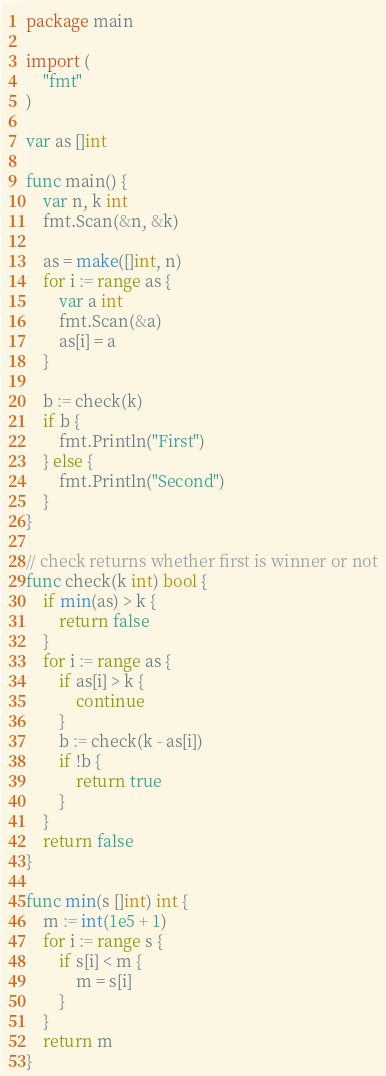<code> <loc_0><loc_0><loc_500><loc_500><_Go_>package main

import (
    "fmt"
)

var as []int

func main() {
    var n, k int
    fmt.Scan(&n, &k)

    as = make([]int, n)
    for i := range as {
        var a int
        fmt.Scan(&a)
        as[i] = a
    }

    b := check(k)
    if b {
        fmt.Println("First")
    } else {
        fmt.Println("Second")
    }
}

// check returns whether first is winner or not
func check(k int) bool {
    if min(as) > k {
        return false
    }
    for i := range as {
        if as[i] > k {
            continue
        }
        b := check(k - as[i])
        if !b {
            return true
        }
    }
    return false
}

func min(s []int) int {
    m := int(1e5 + 1)
    for i := range s {
        if s[i] < m {
            m = s[i]
        }
    }
    return m
}
</code> 